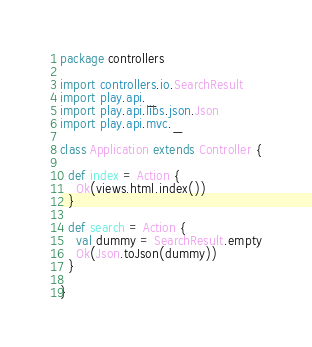<code> <loc_0><loc_0><loc_500><loc_500><_Scala_>package controllers

import controllers.io.SearchResult
import play.api._
import play.api.libs.json.Json
import play.api.mvc._

class Application extends Controller {

  def index = Action {
    Ok(views.html.index())
  }

  def search = Action {
    val dummy = SearchResult.empty
    Ok(Json.toJson(dummy))
  }

}
</code> 